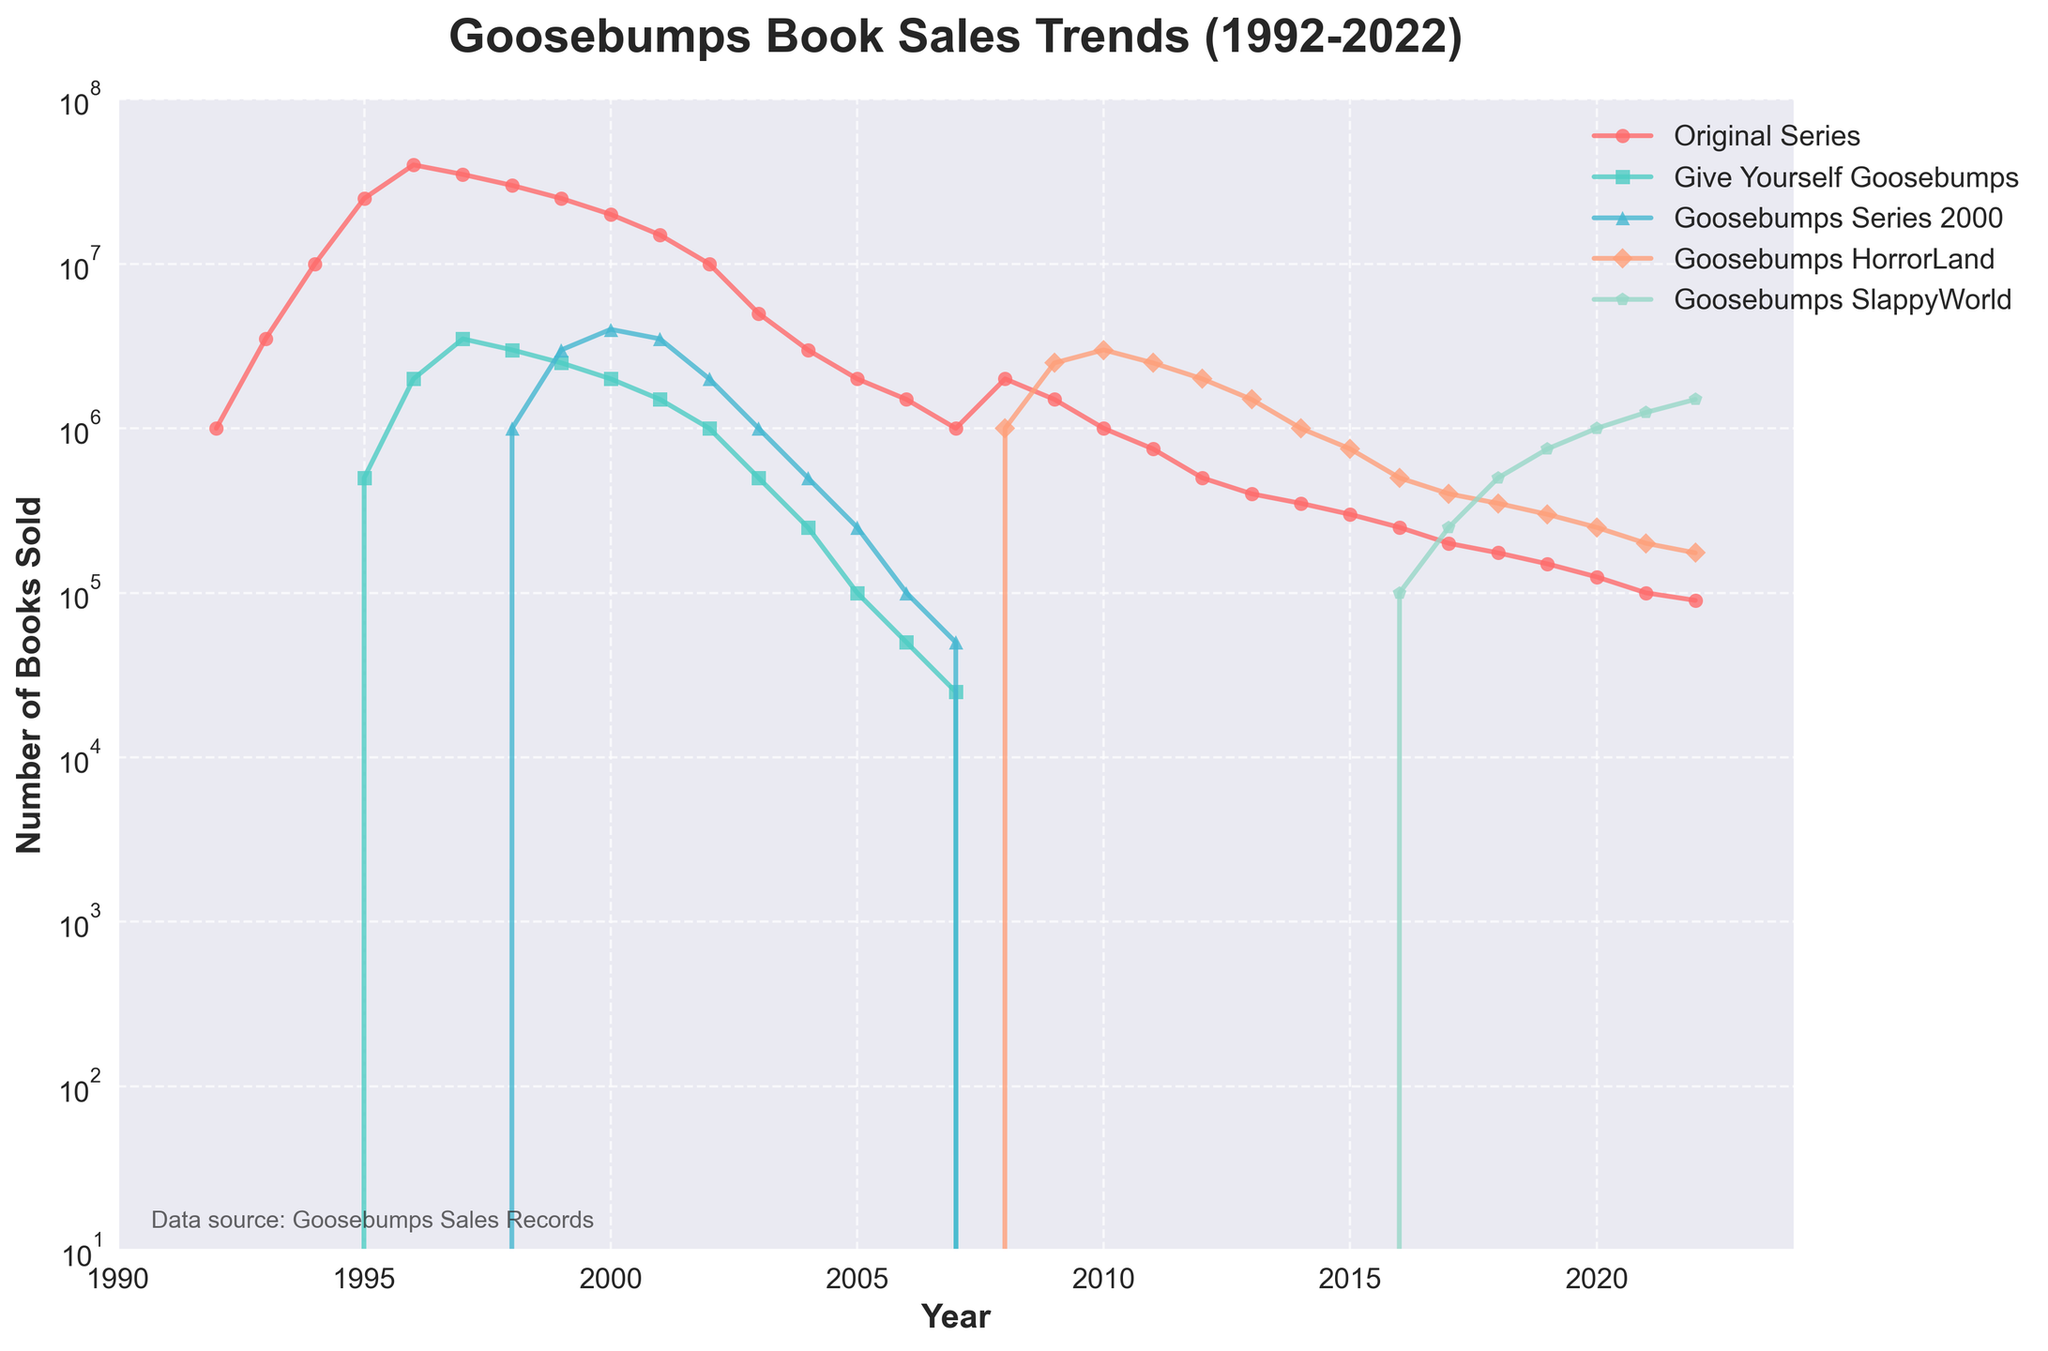How did the sales of the Original Series change from 1992 to 1995? The sales increased from 1,000,000 in 1992 to 25,000,000 in 1995. This can be observed as a rise in the line representing the Original Series in the chart.
Answer: Increased to 25,000,000 Which series showed the highest peak in sales and in which year? The Original Series had the highest peak in 1996 with sales of 40,000,000. This can be seen by identifying the highest point on the chart.
Answer: Original Series in 1996 Compare the sales of Goosebumps HorrorLand in 2010 and 2011. In 2010, Goosebumps HorrorLand had 3,000,000 sales, whereas in 2011 it had 2,500,000 sales. By examining the Goosebumps HorrorLand line, one can observe the decline.
Answer: Decreased to 2,500,000 What is the trend in sales for the Give Yourself Goosebumps series from 1995 to 2007? The sales of the Give Yourself Goosebumps series started at 500,000 in 1995, rose to 3,500,000 in 1997, and gradually declined to approximately 25,000 by 2007. This declining trend is visible as a downward curve.
Answer: Declining trend Between 1997 and 2002, what was the average annual sales for the Goosebumps Series 2000? The sales from 1997 to 2002 were 0, 1,000,000, 3,000,000, 4,000,000, 3,500,000, and 2,000,000 respectively. The average is calculated as (0 + 1,000,000 + 3,000,000 + 4,000,000 + 3,500,000 + 2,000,000) / 6 = 2,083,333.33.
Answer: 2,083,333.33 What is the overall trend of the Goosebumps SlappyWorld series sales from 2016 to 2022? The sales started at 100,000 in 2016 and increased each year to reach 1,500,000 by 2022. This steady increase is seen clearly by tracking the line upwards.
Answer: Increasing trend How did the sales for all series combined change between 1999 and 2003? Summing each series for those years, we get: 1999 (28,000,000), 2000 (26,000,000), 2001 (20,000,000), 2002 (13,000,000), 2003 (6,500,000). The combined sales saw a significant decline over these years.
Answer: Declined significantly In which year did the Goosebumps HorrorLand series first appear and what were its sales in its initial year? The Goosebumps HorrorLand series first appeared in 2008 with initial sales of 1,000,000 as noted by observing the lines start point on the graph.
Answer: 2008, 1,000,000 Compare the sales of the Original Series to Goosebumps SlappyWorld in 2020. The Original Series had 125,000 sales whereas Goosebumps SlappyWorld had 1,000,000 sales in 2020. This comparison is clear by examining the relative heights and labels on the y-axis.
Answer: SlappyWorld had higher sales 